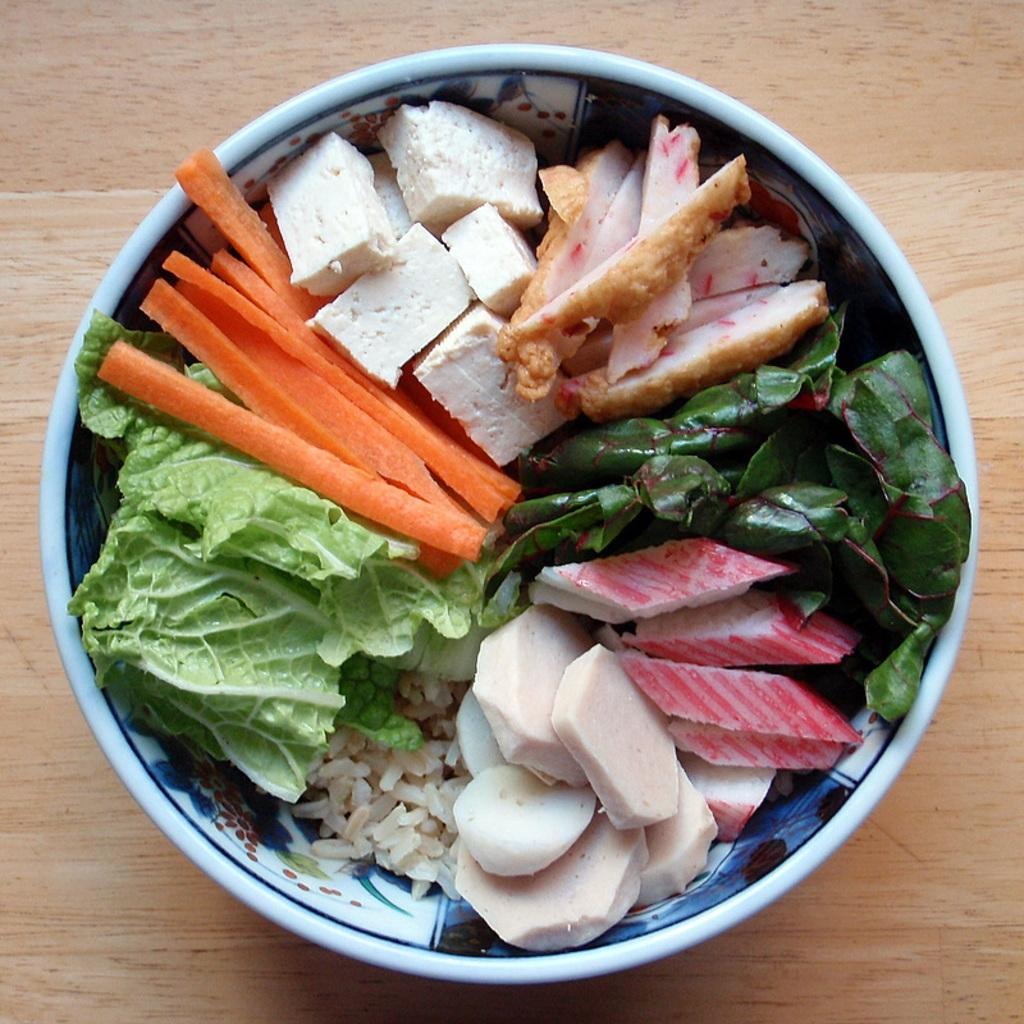What type of food is in the bowl in the image? There are vegetables in a bowl in the image. Where is the bowl located? The bowl is placed on a table. What type of carriage can be seen transporting the vegetables in the image? There is no carriage present in the image; the vegetables are in a bowl on a table. 